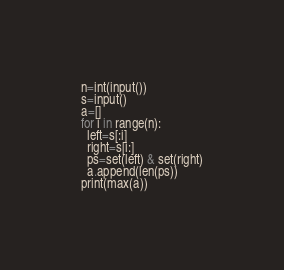Convert code to text. <code><loc_0><loc_0><loc_500><loc_500><_Python_>n=int(input())
s=input()
a=[]
for i in range(n):
  left=s[:i]
  right=s[i:]
  ps=set(left) & set(right)
  a.append(len(ps))
print(max(a))</code> 